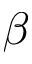Convert formula to latex. <formula><loc_0><loc_0><loc_500><loc_500>\beta</formula> 